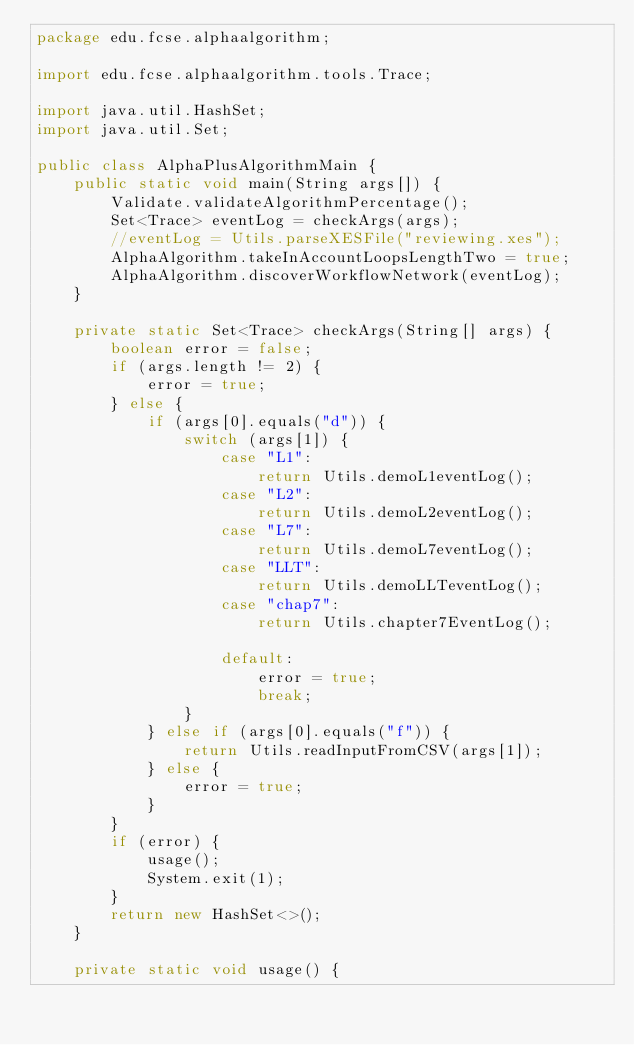<code> <loc_0><loc_0><loc_500><loc_500><_Java_>package edu.fcse.alphaalgorithm;

import edu.fcse.alphaalgorithm.tools.Trace;

import java.util.HashSet;
import java.util.Set;

public class AlphaPlusAlgorithmMain {
    public static void main(String args[]) {
        Validate.validateAlgorithmPercentage();
        Set<Trace> eventLog = checkArgs(args);
        //eventLog = Utils.parseXESFile("reviewing.xes");
        AlphaAlgorithm.takeInAccountLoopsLengthTwo = true;
        AlphaAlgorithm.discoverWorkflowNetwork(eventLog);
    }

    private static Set<Trace> checkArgs(String[] args) {
        boolean error = false;
        if (args.length != 2) {
            error = true;
        } else {
            if (args[0].equals("d")) {
                switch (args[1]) {
                    case "L1":
                        return Utils.demoL1eventLog();
                    case "L2":
                        return Utils.demoL2eventLog();
                    case "L7":
                        return Utils.demoL7eventLog();
                    case "LLT":
                        return Utils.demoLLTeventLog();
                    case "chap7":
                        return Utils.chapter7EventLog();

                    default:
                        error = true;
                        break;
                }
            } else if (args[0].equals("f")) {
                return Utils.readInputFromCSV(args[1]);
            } else {
                error = true;
            }
        }
        if (error) {
            usage();
            System.exit(1);
        }
        return new HashSet<>();
    }

    private static void usage() {</code> 